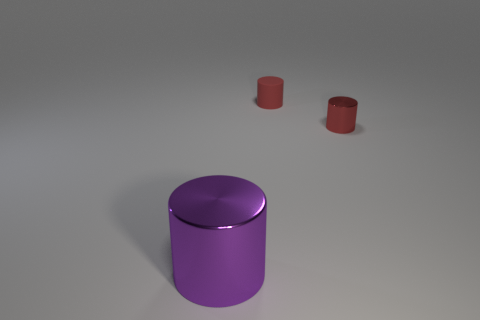There is another tiny thing that is the same color as the rubber thing; what is its material?
Provide a short and direct response. Metal. How many tiny cylinders are behind the tiny red cylinder in front of the small cylinder behind the red metallic object?
Give a very brief answer. 1. What number of tiny red matte cylinders are in front of the red shiny object?
Give a very brief answer. 0. What number of tiny red things are the same material as the large purple thing?
Keep it short and to the point. 1. The other tiny cylinder that is the same material as the purple cylinder is what color?
Keep it short and to the point. Red. There is a cylinder on the right side of the small red matte object on the left side of the shiny cylinder on the right side of the big metal object; what is it made of?
Your response must be concise. Metal. Is the size of the red thing in front of the red matte object the same as the rubber cylinder?
Offer a terse response. Yes. What number of small things are metal cylinders or red cylinders?
Your response must be concise. 2. Are there any other large cylinders of the same color as the big cylinder?
Offer a very short reply. No. There is a object that is the same size as the red rubber cylinder; what shape is it?
Your answer should be very brief. Cylinder. 